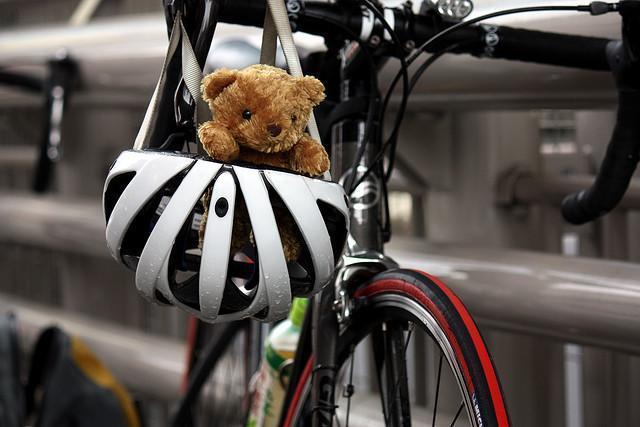Does the caption "The bicycle is beside the teddy bear." correctly depict the image?
Answer yes or no. Yes. Is this affirmation: "The teddy bear is beside the bicycle." correct?
Answer yes or no. Yes. 